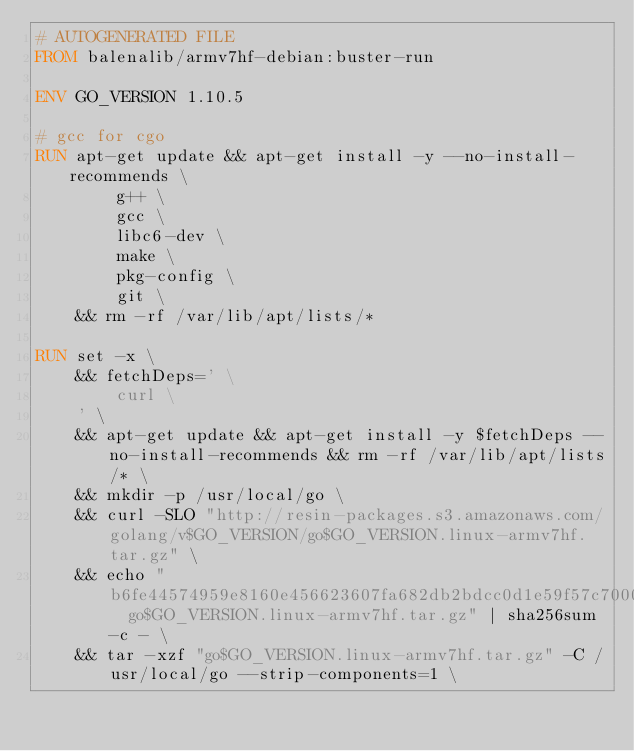Convert code to text. <code><loc_0><loc_0><loc_500><loc_500><_Dockerfile_># AUTOGENERATED FILE
FROM balenalib/armv7hf-debian:buster-run

ENV GO_VERSION 1.10.5

# gcc for cgo
RUN apt-get update && apt-get install -y --no-install-recommends \
		g++ \
		gcc \
		libc6-dev \
		make \
		pkg-config \
		git \
	&& rm -rf /var/lib/apt/lists/*

RUN set -x \
	&& fetchDeps=' \
		curl \
	' \
	&& apt-get update && apt-get install -y $fetchDeps --no-install-recommends && rm -rf /var/lib/apt/lists/* \
	&& mkdir -p /usr/local/go \
	&& curl -SLO "http://resin-packages.s3.amazonaws.com/golang/v$GO_VERSION/go$GO_VERSION.linux-armv7hf.tar.gz" \
	&& echo "b6fe44574959e8160e456623607fa682db2bdcc0d1e59f57c7000fee9455f7b5  go$GO_VERSION.linux-armv7hf.tar.gz" | sha256sum -c - \
	&& tar -xzf "go$GO_VERSION.linux-armv7hf.tar.gz" -C /usr/local/go --strip-components=1 \</code> 